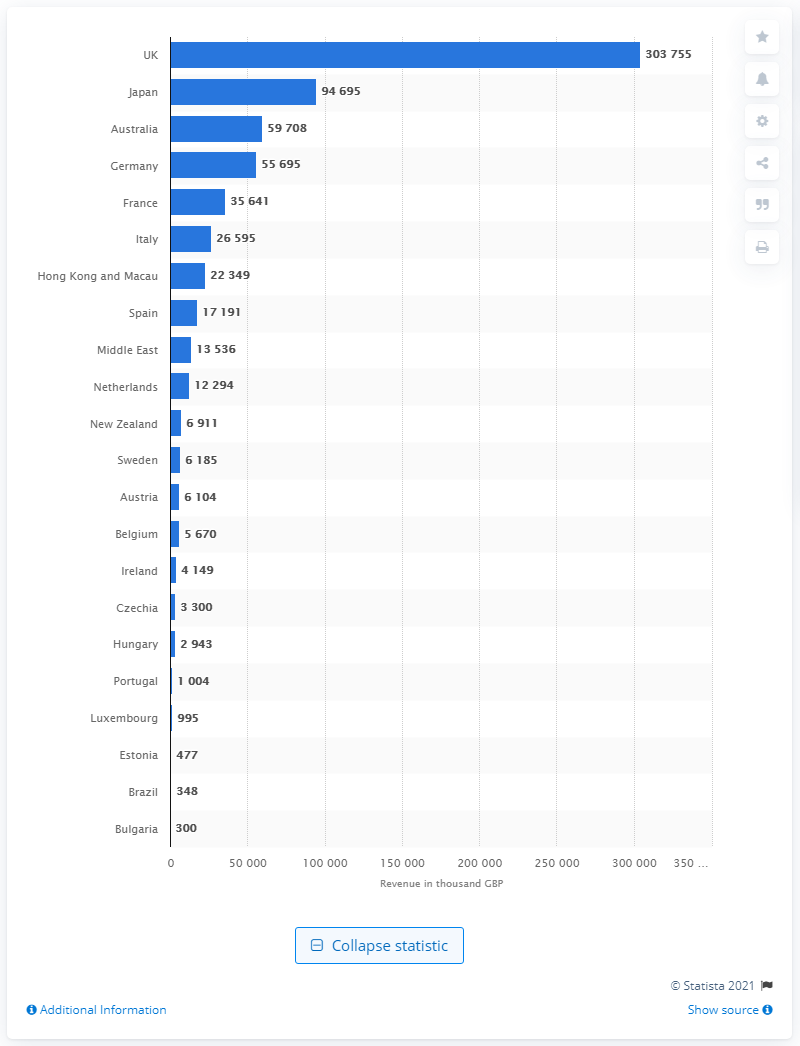Indicate a few pertinent items in this graphic. Lush's retail activities took place in Japan. 